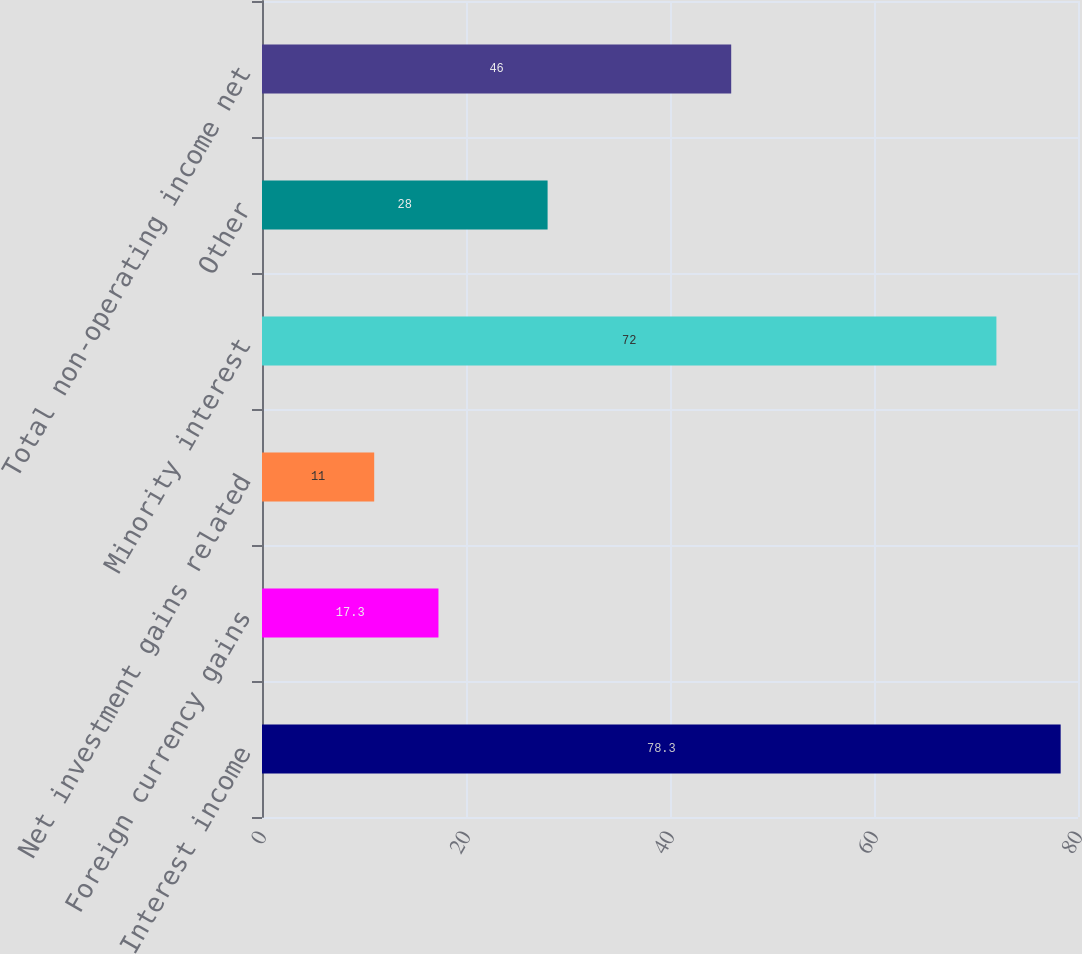Convert chart. <chart><loc_0><loc_0><loc_500><loc_500><bar_chart><fcel>Interest income<fcel>Foreign currency gains<fcel>Net investment gains related<fcel>Minority interest<fcel>Other<fcel>Total non-operating income net<nl><fcel>78.3<fcel>17.3<fcel>11<fcel>72<fcel>28<fcel>46<nl></chart> 